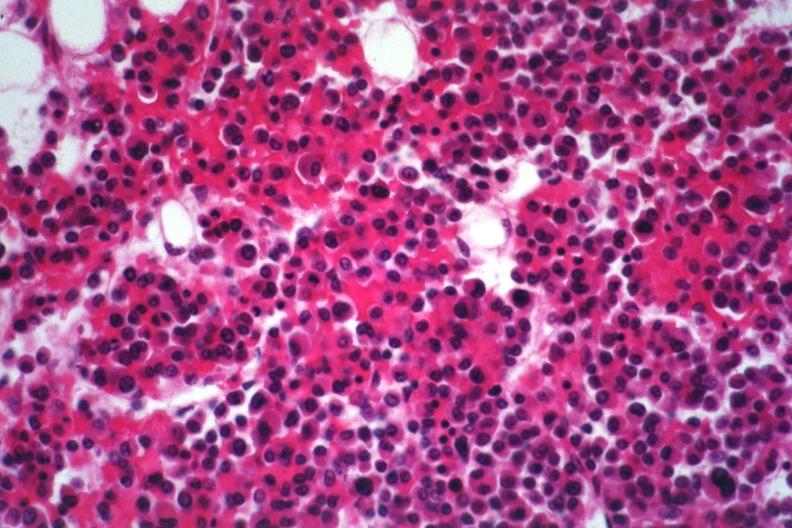s cephalohematoma present?
Answer the question using a single word or phrase. No 